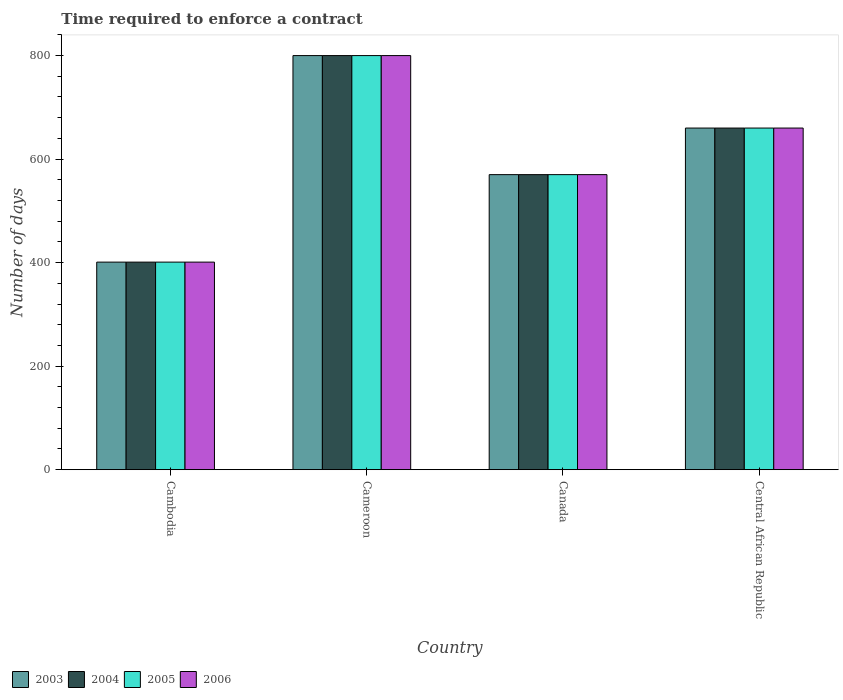What is the label of the 1st group of bars from the left?
Your answer should be compact. Cambodia. What is the number of days required to enforce a contract in 2005 in Cameroon?
Offer a very short reply. 800. Across all countries, what is the maximum number of days required to enforce a contract in 2006?
Offer a very short reply. 800. Across all countries, what is the minimum number of days required to enforce a contract in 2005?
Offer a very short reply. 401. In which country was the number of days required to enforce a contract in 2004 maximum?
Your answer should be very brief. Cameroon. In which country was the number of days required to enforce a contract in 2004 minimum?
Ensure brevity in your answer.  Cambodia. What is the total number of days required to enforce a contract in 2005 in the graph?
Provide a short and direct response. 2431. What is the difference between the number of days required to enforce a contract in 2005 in Cameroon and that in Canada?
Provide a succinct answer. 230. What is the difference between the number of days required to enforce a contract in 2004 in Cambodia and the number of days required to enforce a contract in 2005 in Cameroon?
Your answer should be very brief. -399. What is the average number of days required to enforce a contract in 2004 per country?
Provide a succinct answer. 607.75. What is the ratio of the number of days required to enforce a contract in 2005 in Cambodia to that in Cameroon?
Keep it short and to the point. 0.5. Is the difference between the number of days required to enforce a contract in 2004 in Cambodia and Cameroon greater than the difference between the number of days required to enforce a contract in 2003 in Cambodia and Cameroon?
Make the answer very short. No. What is the difference between the highest and the second highest number of days required to enforce a contract in 2005?
Provide a short and direct response. 230. What is the difference between the highest and the lowest number of days required to enforce a contract in 2005?
Your answer should be compact. 399. In how many countries, is the number of days required to enforce a contract in 2004 greater than the average number of days required to enforce a contract in 2004 taken over all countries?
Your response must be concise. 2. Is the sum of the number of days required to enforce a contract in 2004 in Cameroon and Central African Republic greater than the maximum number of days required to enforce a contract in 2006 across all countries?
Provide a short and direct response. Yes. What does the 3rd bar from the left in Canada represents?
Give a very brief answer. 2005. What does the 1st bar from the right in Cambodia represents?
Provide a succinct answer. 2006. How many countries are there in the graph?
Offer a terse response. 4. What is the difference between two consecutive major ticks on the Y-axis?
Give a very brief answer. 200. Does the graph contain any zero values?
Offer a very short reply. No. Where does the legend appear in the graph?
Provide a short and direct response. Bottom left. What is the title of the graph?
Offer a terse response. Time required to enforce a contract. What is the label or title of the Y-axis?
Offer a very short reply. Number of days. What is the Number of days in 2003 in Cambodia?
Offer a very short reply. 401. What is the Number of days of 2004 in Cambodia?
Give a very brief answer. 401. What is the Number of days in 2005 in Cambodia?
Provide a short and direct response. 401. What is the Number of days in 2006 in Cambodia?
Your answer should be compact. 401. What is the Number of days in 2003 in Cameroon?
Offer a very short reply. 800. What is the Number of days in 2004 in Cameroon?
Provide a succinct answer. 800. What is the Number of days of 2005 in Cameroon?
Your answer should be compact. 800. What is the Number of days of 2006 in Cameroon?
Your answer should be very brief. 800. What is the Number of days of 2003 in Canada?
Your response must be concise. 570. What is the Number of days in 2004 in Canada?
Make the answer very short. 570. What is the Number of days in 2005 in Canada?
Your answer should be compact. 570. What is the Number of days of 2006 in Canada?
Offer a very short reply. 570. What is the Number of days in 2003 in Central African Republic?
Provide a succinct answer. 660. What is the Number of days of 2004 in Central African Republic?
Your response must be concise. 660. What is the Number of days in 2005 in Central African Republic?
Your answer should be very brief. 660. What is the Number of days in 2006 in Central African Republic?
Make the answer very short. 660. Across all countries, what is the maximum Number of days of 2003?
Make the answer very short. 800. Across all countries, what is the maximum Number of days in 2004?
Ensure brevity in your answer.  800. Across all countries, what is the maximum Number of days of 2005?
Offer a terse response. 800. Across all countries, what is the maximum Number of days in 2006?
Ensure brevity in your answer.  800. Across all countries, what is the minimum Number of days of 2003?
Offer a very short reply. 401. Across all countries, what is the minimum Number of days of 2004?
Ensure brevity in your answer.  401. Across all countries, what is the minimum Number of days in 2005?
Your response must be concise. 401. Across all countries, what is the minimum Number of days in 2006?
Give a very brief answer. 401. What is the total Number of days in 2003 in the graph?
Offer a terse response. 2431. What is the total Number of days of 2004 in the graph?
Ensure brevity in your answer.  2431. What is the total Number of days of 2005 in the graph?
Offer a very short reply. 2431. What is the total Number of days of 2006 in the graph?
Ensure brevity in your answer.  2431. What is the difference between the Number of days in 2003 in Cambodia and that in Cameroon?
Your response must be concise. -399. What is the difference between the Number of days in 2004 in Cambodia and that in Cameroon?
Offer a terse response. -399. What is the difference between the Number of days of 2005 in Cambodia and that in Cameroon?
Ensure brevity in your answer.  -399. What is the difference between the Number of days of 2006 in Cambodia and that in Cameroon?
Keep it short and to the point. -399. What is the difference between the Number of days in 2003 in Cambodia and that in Canada?
Provide a succinct answer. -169. What is the difference between the Number of days in 2004 in Cambodia and that in Canada?
Offer a very short reply. -169. What is the difference between the Number of days of 2005 in Cambodia and that in Canada?
Make the answer very short. -169. What is the difference between the Number of days in 2006 in Cambodia and that in Canada?
Your answer should be very brief. -169. What is the difference between the Number of days in 2003 in Cambodia and that in Central African Republic?
Your response must be concise. -259. What is the difference between the Number of days in 2004 in Cambodia and that in Central African Republic?
Your response must be concise. -259. What is the difference between the Number of days of 2005 in Cambodia and that in Central African Republic?
Your answer should be very brief. -259. What is the difference between the Number of days of 2006 in Cambodia and that in Central African Republic?
Ensure brevity in your answer.  -259. What is the difference between the Number of days in 2003 in Cameroon and that in Canada?
Offer a terse response. 230. What is the difference between the Number of days of 2004 in Cameroon and that in Canada?
Keep it short and to the point. 230. What is the difference between the Number of days in 2005 in Cameroon and that in Canada?
Offer a terse response. 230. What is the difference between the Number of days of 2006 in Cameroon and that in Canada?
Ensure brevity in your answer.  230. What is the difference between the Number of days in 2003 in Cameroon and that in Central African Republic?
Offer a terse response. 140. What is the difference between the Number of days in 2004 in Cameroon and that in Central African Republic?
Your answer should be compact. 140. What is the difference between the Number of days in 2005 in Cameroon and that in Central African Republic?
Your answer should be very brief. 140. What is the difference between the Number of days of 2006 in Cameroon and that in Central African Republic?
Provide a succinct answer. 140. What is the difference between the Number of days of 2003 in Canada and that in Central African Republic?
Provide a short and direct response. -90. What is the difference between the Number of days in 2004 in Canada and that in Central African Republic?
Offer a terse response. -90. What is the difference between the Number of days in 2005 in Canada and that in Central African Republic?
Your answer should be compact. -90. What is the difference between the Number of days of 2006 in Canada and that in Central African Republic?
Give a very brief answer. -90. What is the difference between the Number of days in 2003 in Cambodia and the Number of days in 2004 in Cameroon?
Keep it short and to the point. -399. What is the difference between the Number of days in 2003 in Cambodia and the Number of days in 2005 in Cameroon?
Provide a short and direct response. -399. What is the difference between the Number of days in 2003 in Cambodia and the Number of days in 2006 in Cameroon?
Keep it short and to the point. -399. What is the difference between the Number of days of 2004 in Cambodia and the Number of days of 2005 in Cameroon?
Keep it short and to the point. -399. What is the difference between the Number of days in 2004 in Cambodia and the Number of days in 2006 in Cameroon?
Your response must be concise. -399. What is the difference between the Number of days in 2005 in Cambodia and the Number of days in 2006 in Cameroon?
Offer a very short reply. -399. What is the difference between the Number of days of 2003 in Cambodia and the Number of days of 2004 in Canada?
Your response must be concise. -169. What is the difference between the Number of days in 2003 in Cambodia and the Number of days in 2005 in Canada?
Provide a short and direct response. -169. What is the difference between the Number of days of 2003 in Cambodia and the Number of days of 2006 in Canada?
Provide a succinct answer. -169. What is the difference between the Number of days of 2004 in Cambodia and the Number of days of 2005 in Canada?
Ensure brevity in your answer.  -169. What is the difference between the Number of days of 2004 in Cambodia and the Number of days of 2006 in Canada?
Your response must be concise. -169. What is the difference between the Number of days in 2005 in Cambodia and the Number of days in 2006 in Canada?
Your answer should be very brief. -169. What is the difference between the Number of days of 2003 in Cambodia and the Number of days of 2004 in Central African Republic?
Keep it short and to the point. -259. What is the difference between the Number of days in 2003 in Cambodia and the Number of days in 2005 in Central African Republic?
Your answer should be very brief. -259. What is the difference between the Number of days in 2003 in Cambodia and the Number of days in 2006 in Central African Republic?
Make the answer very short. -259. What is the difference between the Number of days in 2004 in Cambodia and the Number of days in 2005 in Central African Republic?
Provide a succinct answer. -259. What is the difference between the Number of days in 2004 in Cambodia and the Number of days in 2006 in Central African Republic?
Ensure brevity in your answer.  -259. What is the difference between the Number of days in 2005 in Cambodia and the Number of days in 2006 in Central African Republic?
Keep it short and to the point. -259. What is the difference between the Number of days in 2003 in Cameroon and the Number of days in 2004 in Canada?
Provide a succinct answer. 230. What is the difference between the Number of days of 2003 in Cameroon and the Number of days of 2005 in Canada?
Your answer should be compact. 230. What is the difference between the Number of days of 2003 in Cameroon and the Number of days of 2006 in Canada?
Provide a short and direct response. 230. What is the difference between the Number of days in 2004 in Cameroon and the Number of days in 2005 in Canada?
Give a very brief answer. 230. What is the difference between the Number of days of 2004 in Cameroon and the Number of days of 2006 in Canada?
Your answer should be very brief. 230. What is the difference between the Number of days in 2005 in Cameroon and the Number of days in 2006 in Canada?
Provide a succinct answer. 230. What is the difference between the Number of days of 2003 in Cameroon and the Number of days of 2004 in Central African Republic?
Give a very brief answer. 140. What is the difference between the Number of days in 2003 in Cameroon and the Number of days in 2005 in Central African Republic?
Make the answer very short. 140. What is the difference between the Number of days in 2003 in Cameroon and the Number of days in 2006 in Central African Republic?
Keep it short and to the point. 140. What is the difference between the Number of days of 2004 in Cameroon and the Number of days of 2005 in Central African Republic?
Your answer should be compact. 140. What is the difference between the Number of days of 2004 in Cameroon and the Number of days of 2006 in Central African Republic?
Give a very brief answer. 140. What is the difference between the Number of days in 2005 in Cameroon and the Number of days in 2006 in Central African Republic?
Provide a short and direct response. 140. What is the difference between the Number of days in 2003 in Canada and the Number of days in 2004 in Central African Republic?
Make the answer very short. -90. What is the difference between the Number of days in 2003 in Canada and the Number of days in 2005 in Central African Republic?
Make the answer very short. -90. What is the difference between the Number of days of 2003 in Canada and the Number of days of 2006 in Central African Republic?
Offer a very short reply. -90. What is the difference between the Number of days in 2004 in Canada and the Number of days in 2005 in Central African Republic?
Your answer should be very brief. -90. What is the difference between the Number of days of 2004 in Canada and the Number of days of 2006 in Central African Republic?
Keep it short and to the point. -90. What is the difference between the Number of days of 2005 in Canada and the Number of days of 2006 in Central African Republic?
Your answer should be very brief. -90. What is the average Number of days of 2003 per country?
Keep it short and to the point. 607.75. What is the average Number of days in 2004 per country?
Offer a very short reply. 607.75. What is the average Number of days of 2005 per country?
Ensure brevity in your answer.  607.75. What is the average Number of days in 2006 per country?
Keep it short and to the point. 607.75. What is the difference between the Number of days of 2003 and Number of days of 2004 in Cambodia?
Your response must be concise. 0. What is the difference between the Number of days in 2003 and Number of days in 2005 in Cambodia?
Your answer should be compact. 0. What is the difference between the Number of days in 2004 and Number of days in 2006 in Cambodia?
Your answer should be very brief. 0. What is the difference between the Number of days of 2005 and Number of days of 2006 in Cambodia?
Provide a short and direct response. 0. What is the difference between the Number of days in 2003 and Number of days in 2005 in Cameroon?
Provide a short and direct response. 0. What is the difference between the Number of days of 2004 and Number of days of 2005 in Cameroon?
Offer a terse response. 0. What is the difference between the Number of days in 2005 and Number of days in 2006 in Cameroon?
Offer a very short reply. 0. What is the difference between the Number of days in 2003 and Number of days in 2004 in Canada?
Ensure brevity in your answer.  0. What is the difference between the Number of days in 2003 and Number of days in 2006 in Canada?
Keep it short and to the point. 0. What is the difference between the Number of days in 2004 and Number of days in 2005 in Canada?
Ensure brevity in your answer.  0. What is the difference between the Number of days in 2003 and Number of days in 2004 in Central African Republic?
Provide a succinct answer. 0. What is the difference between the Number of days of 2003 and Number of days of 2006 in Central African Republic?
Make the answer very short. 0. What is the difference between the Number of days in 2004 and Number of days in 2005 in Central African Republic?
Give a very brief answer. 0. What is the difference between the Number of days in 2004 and Number of days in 2006 in Central African Republic?
Provide a short and direct response. 0. What is the ratio of the Number of days of 2003 in Cambodia to that in Cameroon?
Give a very brief answer. 0.5. What is the ratio of the Number of days of 2004 in Cambodia to that in Cameroon?
Give a very brief answer. 0.5. What is the ratio of the Number of days in 2005 in Cambodia to that in Cameroon?
Give a very brief answer. 0.5. What is the ratio of the Number of days in 2006 in Cambodia to that in Cameroon?
Offer a very short reply. 0.5. What is the ratio of the Number of days in 2003 in Cambodia to that in Canada?
Give a very brief answer. 0.7. What is the ratio of the Number of days of 2004 in Cambodia to that in Canada?
Offer a terse response. 0.7. What is the ratio of the Number of days of 2005 in Cambodia to that in Canada?
Ensure brevity in your answer.  0.7. What is the ratio of the Number of days in 2006 in Cambodia to that in Canada?
Offer a very short reply. 0.7. What is the ratio of the Number of days of 2003 in Cambodia to that in Central African Republic?
Your answer should be very brief. 0.61. What is the ratio of the Number of days of 2004 in Cambodia to that in Central African Republic?
Give a very brief answer. 0.61. What is the ratio of the Number of days of 2005 in Cambodia to that in Central African Republic?
Keep it short and to the point. 0.61. What is the ratio of the Number of days in 2006 in Cambodia to that in Central African Republic?
Provide a succinct answer. 0.61. What is the ratio of the Number of days in 2003 in Cameroon to that in Canada?
Provide a short and direct response. 1.4. What is the ratio of the Number of days in 2004 in Cameroon to that in Canada?
Make the answer very short. 1.4. What is the ratio of the Number of days of 2005 in Cameroon to that in Canada?
Your response must be concise. 1.4. What is the ratio of the Number of days of 2006 in Cameroon to that in Canada?
Keep it short and to the point. 1.4. What is the ratio of the Number of days of 2003 in Cameroon to that in Central African Republic?
Offer a terse response. 1.21. What is the ratio of the Number of days in 2004 in Cameroon to that in Central African Republic?
Offer a terse response. 1.21. What is the ratio of the Number of days of 2005 in Cameroon to that in Central African Republic?
Ensure brevity in your answer.  1.21. What is the ratio of the Number of days in 2006 in Cameroon to that in Central African Republic?
Your answer should be very brief. 1.21. What is the ratio of the Number of days of 2003 in Canada to that in Central African Republic?
Offer a terse response. 0.86. What is the ratio of the Number of days of 2004 in Canada to that in Central African Republic?
Ensure brevity in your answer.  0.86. What is the ratio of the Number of days of 2005 in Canada to that in Central African Republic?
Your answer should be very brief. 0.86. What is the ratio of the Number of days of 2006 in Canada to that in Central African Republic?
Make the answer very short. 0.86. What is the difference between the highest and the second highest Number of days in 2003?
Your answer should be compact. 140. What is the difference between the highest and the second highest Number of days of 2004?
Make the answer very short. 140. What is the difference between the highest and the second highest Number of days of 2005?
Ensure brevity in your answer.  140. What is the difference between the highest and the second highest Number of days in 2006?
Keep it short and to the point. 140. What is the difference between the highest and the lowest Number of days of 2003?
Your response must be concise. 399. What is the difference between the highest and the lowest Number of days of 2004?
Your answer should be very brief. 399. What is the difference between the highest and the lowest Number of days of 2005?
Give a very brief answer. 399. What is the difference between the highest and the lowest Number of days of 2006?
Provide a short and direct response. 399. 